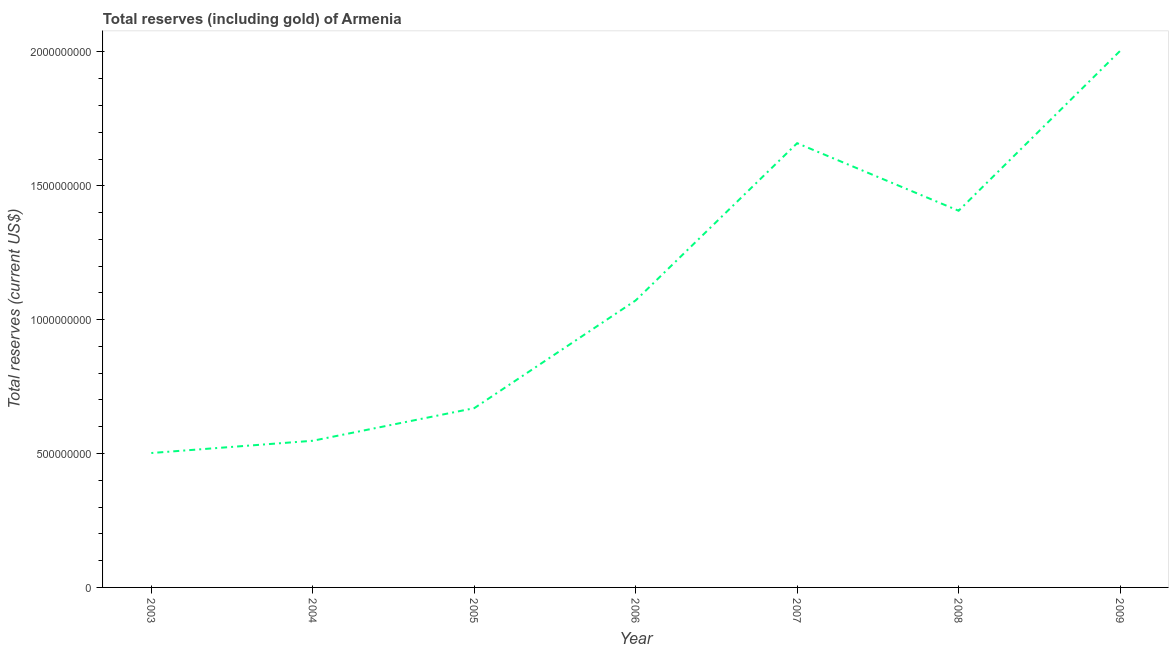What is the total reserves (including gold) in 2007?
Offer a very short reply. 1.66e+09. Across all years, what is the maximum total reserves (including gold)?
Provide a short and direct response. 2.00e+09. Across all years, what is the minimum total reserves (including gold)?
Your answer should be compact. 5.02e+08. In which year was the total reserves (including gold) maximum?
Your answer should be compact. 2009. What is the sum of the total reserves (including gold)?
Your response must be concise. 7.86e+09. What is the difference between the total reserves (including gold) in 2007 and 2009?
Your response must be concise. -3.45e+08. What is the average total reserves (including gold) per year?
Your answer should be compact. 1.12e+09. What is the median total reserves (including gold)?
Make the answer very short. 1.07e+09. In how many years, is the total reserves (including gold) greater than 300000000 US$?
Your response must be concise. 7. What is the ratio of the total reserves (including gold) in 2004 to that in 2005?
Your answer should be very brief. 0.82. Is the total reserves (including gold) in 2004 less than that in 2005?
Offer a terse response. Yes. Is the difference between the total reserves (including gold) in 2004 and 2006 greater than the difference between any two years?
Offer a very short reply. No. What is the difference between the highest and the second highest total reserves (including gold)?
Your answer should be very brief. 3.45e+08. Is the sum of the total reserves (including gold) in 2004 and 2009 greater than the maximum total reserves (including gold) across all years?
Ensure brevity in your answer.  Yes. What is the difference between the highest and the lowest total reserves (including gold)?
Offer a terse response. 1.50e+09. In how many years, is the total reserves (including gold) greater than the average total reserves (including gold) taken over all years?
Offer a very short reply. 3. What is the difference between two consecutive major ticks on the Y-axis?
Keep it short and to the point. 5.00e+08. Does the graph contain any zero values?
Provide a short and direct response. No. Does the graph contain grids?
Offer a terse response. No. What is the title of the graph?
Your response must be concise. Total reserves (including gold) of Armenia. What is the label or title of the Y-axis?
Keep it short and to the point. Total reserves (current US$). What is the Total reserves (current US$) in 2003?
Ensure brevity in your answer.  5.02e+08. What is the Total reserves (current US$) of 2004?
Keep it short and to the point. 5.48e+08. What is the Total reserves (current US$) of 2005?
Your response must be concise. 6.69e+08. What is the Total reserves (current US$) of 2006?
Give a very brief answer. 1.07e+09. What is the Total reserves (current US$) of 2007?
Offer a very short reply. 1.66e+09. What is the Total reserves (current US$) of 2008?
Provide a short and direct response. 1.41e+09. What is the Total reserves (current US$) in 2009?
Provide a short and direct response. 2.00e+09. What is the difference between the Total reserves (current US$) in 2003 and 2004?
Make the answer very short. -4.58e+07. What is the difference between the Total reserves (current US$) in 2003 and 2005?
Your answer should be very brief. -1.68e+08. What is the difference between the Total reserves (current US$) in 2003 and 2006?
Provide a succinct answer. -5.70e+08. What is the difference between the Total reserves (current US$) in 2003 and 2007?
Offer a very short reply. -1.16e+09. What is the difference between the Total reserves (current US$) in 2003 and 2008?
Your answer should be very brief. -9.05e+08. What is the difference between the Total reserves (current US$) in 2003 and 2009?
Your answer should be compact. -1.50e+09. What is the difference between the Total reserves (current US$) in 2004 and 2005?
Offer a terse response. -1.22e+08. What is the difference between the Total reserves (current US$) in 2004 and 2006?
Ensure brevity in your answer.  -5.24e+08. What is the difference between the Total reserves (current US$) in 2004 and 2007?
Provide a short and direct response. -1.11e+09. What is the difference between the Total reserves (current US$) in 2004 and 2008?
Offer a very short reply. -8.59e+08. What is the difference between the Total reserves (current US$) in 2004 and 2009?
Ensure brevity in your answer.  -1.46e+09. What is the difference between the Total reserves (current US$) in 2005 and 2006?
Provide a short and direct response. -4.02e+08. What is the difference between the Total reserves (current US$) in 2005 and 2007?
Your response must be concise. -9.90e+08. What is the difference between the Total reserves (current US$) in 2005 and 2008?
Offer a very short reply. -7.37e+08. What is the difference between the Total reserves (current US$) in 2005 and 2009?
Your answer should be very brief. -1.33e+09. What is the difference between the Total reserves (current US$) in 2006 and 2007?
Give a very brief answer. -5.87e+08. What is the difference between the Total reserves (current US$) in 2006 and 2008?
Your answer should be very brief. -3.35e+08. What is the difference between the Total reserves (current US$) in 2006 and 2009?
Provide a short and direct response. -9.32e+08. What is the difference between the Total reserves (current US$) in 2007 and 2008?
Keep it short and to the point. 2.52e+08. What is the difference between the Total reserves (current US$) in 2007 and 2009?
Your response must be concise. -3.45e+08. What is the difference between the Total reserves (current US$) in 2008 and 2009?
Provide a short and direct response. -5.97e+08. What is the ratio of the Total reserves (current US$) in 2003 to that in 2004?
Keep it short and to the point. 0.92. What is the ratio of the Total reserves (current US$) in 2003 to that in 2005?
Offer a terse response. 0.75. What is the ratio of the Total reserves (current US$) in 2003 to that in 2006?
Ensure brevity in your answer.  0.47. What is the ratio of the Total reserves (current US$) in 2003 to that in 2007?
Give a very brief answer. 0.3. What is the ratio of the Total reserves (current US$) in 2003 to that in 2008?
Give a very brief answer. 0.36. What is the ratio of the Total reserves (current US$) in 2003 to that in 2009?
Offer a terse response. 0.25. What is the ratio of the Total reserves (current US$) in 2004 to that in 2005?
Make the answer very short. 0.82. What is the ratio of the Total reserves (current US$) in 2004 to that in 2006?
Ensure brevity in your answer.  0.51. What is the ratio of the Total reserves (current US$) in 2004 to that in 2007?
Make the answer very short. 0.33. What is the ratio of the Total reserves (current US$) in 2004 to that in 2008?
Make the answer very short. 0.39. What is the ratio of the Total reserves (current US$) in 2004 to that in 2009?
Provide a short and direct response. 0.27. What is the ratio of the Total reserves (current US$) in 2005 to that in 2006?
Provide a short and direct response. 0.62. What is the ratio of the Total reserves (current US$) in 2005 to that in 2007?
Give a very brief answer. 0.4. What is the ratio of the Total reserves (current US$) in 2005 to that in 2008?
Your answer should be very brief. 0.48. What is the ratio of the Total reserves (current US$) in 2005 to that in 2009?
Offer a terse response. 0.33. What is the ratio of the Total reserves (current US$) in 2006 to that in 2007?
Make the answer very short. 0.65. What is the ratio of the Total reserves (current US$) in 2006 to that in 2008?
Your answer should be very brief. 0.76. What is the ratio of the Total reserves (current US$) in 2006 to that in 2009?
Ensure brevity in your answer.  0.54. What is the ratio of the Total reserves (current US$) in 2007 to that in 2008?
Make the answer very short. 1.18. What is the ratio of the Total reserves (current US$) in 2007 to that in 2009?
Your answer should be compact. 0.83. What is the ratio of the Total reserves (current US$) in 2008 to that in 2009?
Offer a terse response. 0.7. 